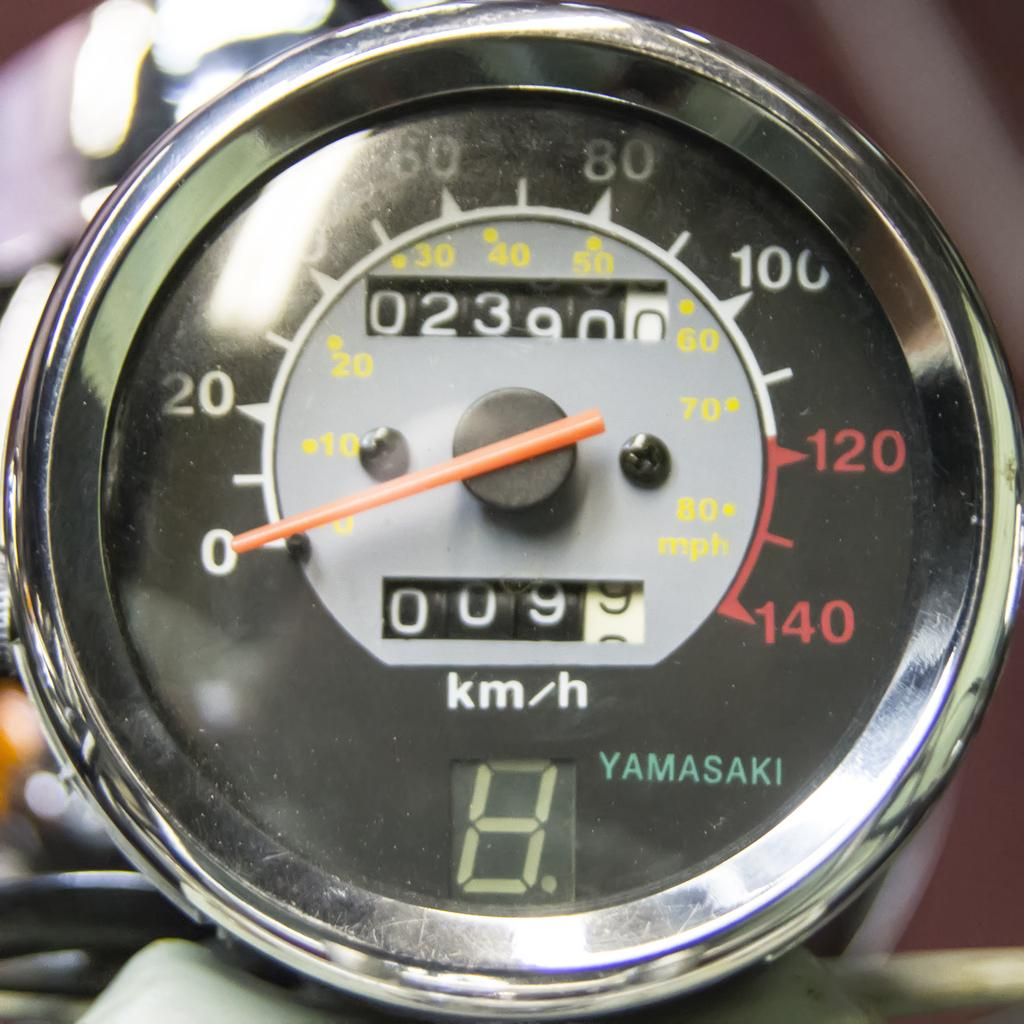<image>
Create a compact narrative representing the image presented. A Yamasaki motorcycle tachometer with 2390 miles listed. 